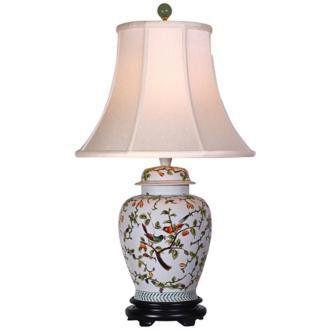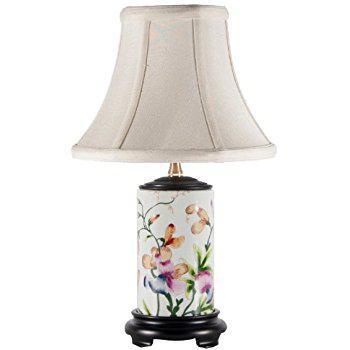The first image is the image on the left, the second image is the image on the right. Analyze the images presented: Is the assertion "In at least one image there is a  white porcelain lamp with two birds facing each other  etched in to the base." valid? Answer yes or no. Yes. The first image is the image on the left, the second image is the image on the right. Given the left and right images, does the statement "The ceramic base of the lamp on the right has a fuller top and tapers toward the bottom, and the base of the lamp on the left is decorated with a bird and flowers and has a dark footed bottom." hold true? Answer yes or no. No. 